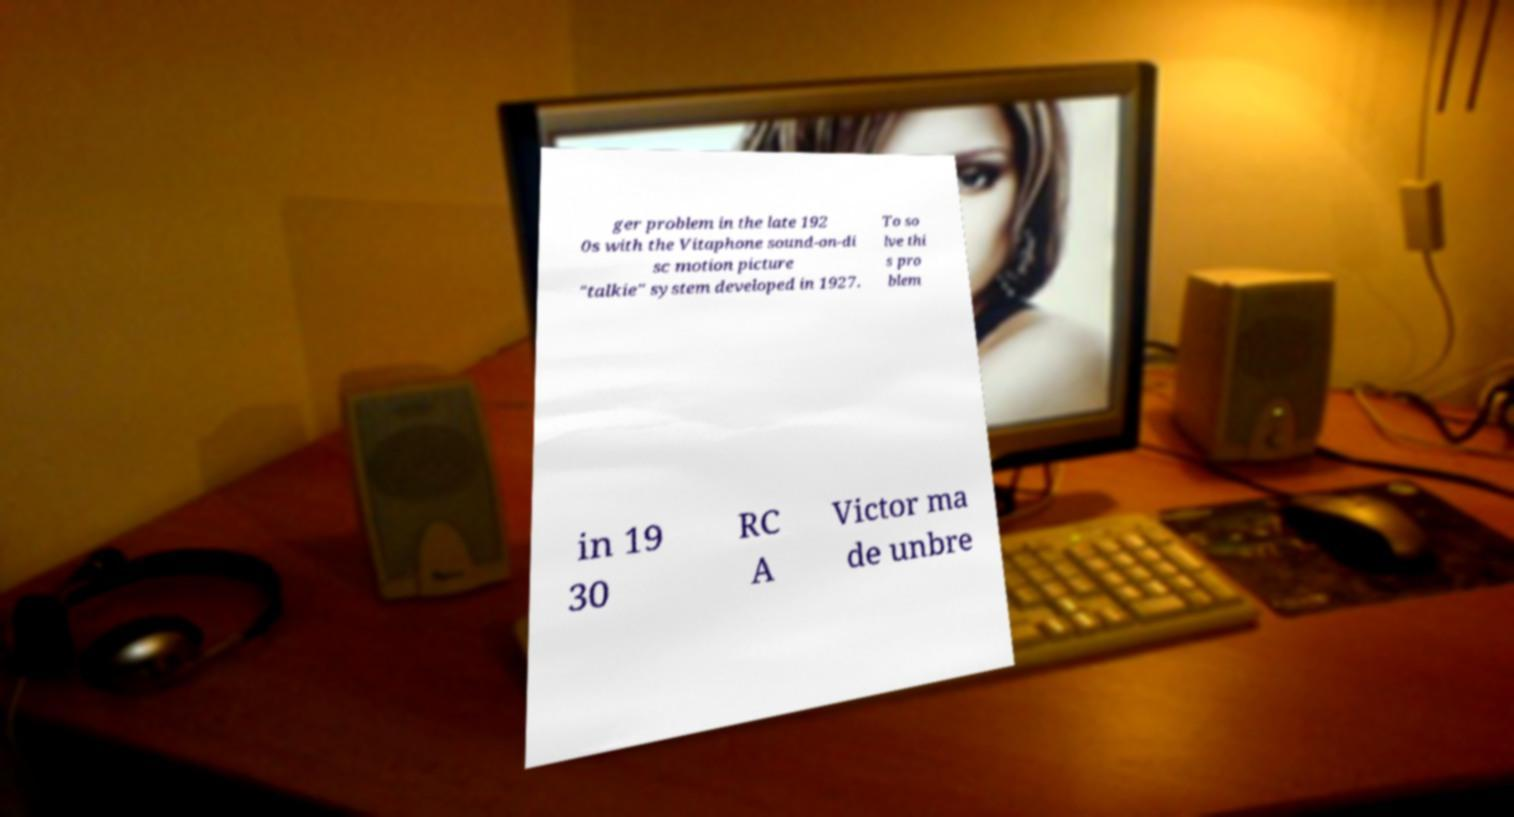Can you accurately transcribe the text from the provided image for me? ger problem in the late 192 0s with the Vitaphone sound-on-di sc motion picture "talkie" system developed in 1927. To so lve thi s pro blem in 19 30 RC A Victor ma de unbre 